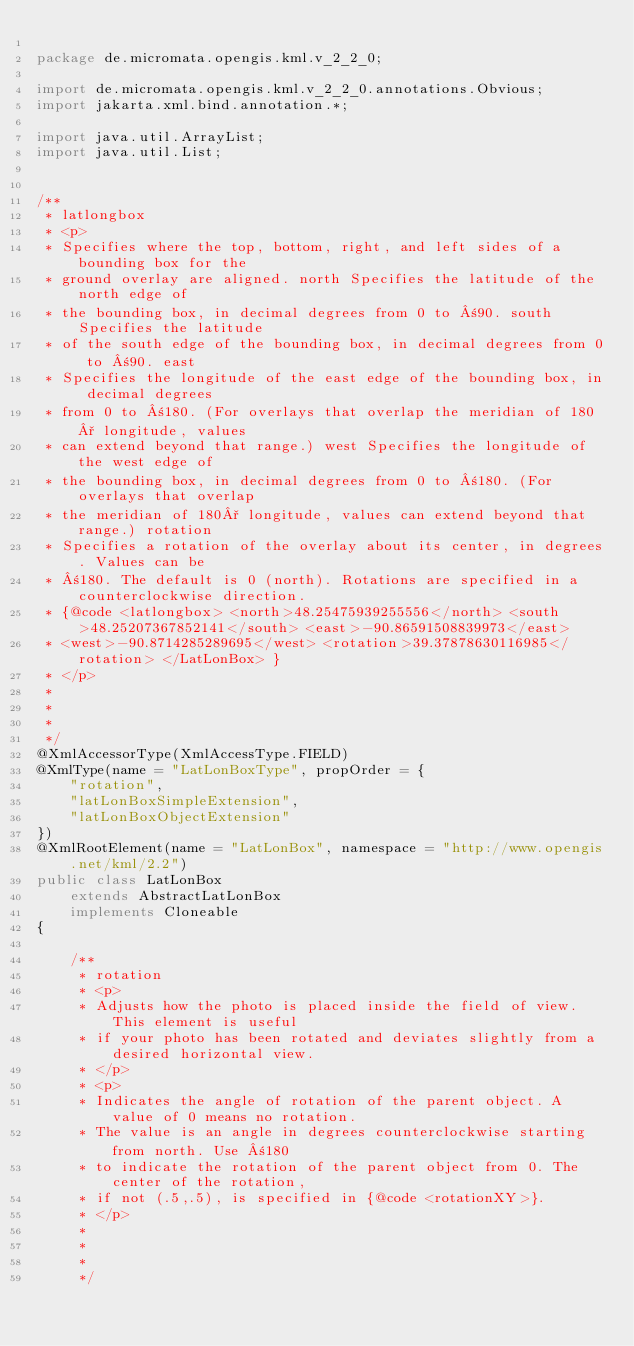<code> <loc_0><loc_0><loc_500><loc_500><_Java_>
package de.micromata.opengis.kml.v_2_2_0;

import de.micromata.opengis.kml.v_2_2_0.annotations.Obvious;
import jakarta.xml.bind.annotation.*;

import java.util.ArrayList;
import java.util.List;


/**
 * latlongbox
 * <p>
 * Specifies where the top, bottom, right, and left sides of a bounding box for the 
 * ground overlay are aligned. north Specifies the latitude of the north edge of 
 * the bounding box, in decimal degrees from 0 to ±90. south Specifies the latitude 
 * of the south edge of the bounding box, in decimal degrees from 0 to ±90. east 
 * Specifies the longitude of the east edge of the bounding box, in decimal degrees 
 * from 0 to ±180. (For overlays that overlap the meridian of 180° longitude, values 
 * can extend beyond that range.) west Specifies the longitude of the west edge of 
 * the bounding box, in decimal degrees from 0 to ±180. (For overlays that overlap 
 * the meridian of 180° longitude, values can extend beyond that range.) rotation 
 * Specifies a rotation of the overlay about its center, in degrees. Values can be 
 * ±180. The default is 0 (north). Rotations are specified in a counterclockwise direction. 
 * {@code <latlongbox> <north>48.25475939255556</north> <south>48.25207367852141</south> <east>-90.86591508839973</east>
 * <west>-90.8714285289695</west> <rotation>39.37878630116985</rotation> </LatLonBox> }
 * </p>
 * 
 * 
 * 
 */
@XmlAccessorType(XmlAccessType.FIELD)
@XmlType(name = "LatLonBoxType", propOrder = {
    "rotation",
    "latLonBoxSimpleExtension",
    "latLonBoxObjectExtension"
})
@XmlRootElement(name = "LatLonBox", namespace = "http://www.opengis.net/kml/2.2")
public class LatLonBox
    extends AbstractLatLonBox
    implements Cloneable
{

    /**
     * rotation
     * <p>
     * Adjusts how the photo is placed inside the field of view. This element is useful 
     * if your photo has been rotated and deviates slightly from a desired horizontal view. 
     * </p>
     * <p>
     * Indicates the angle of rotation of the parent object. A value of 0 means no rotation. 
     * The value is an angle in degrees counterclockwise starting from north. Use ±180 
     * to indicate the rotation of the parent object from 0. The center of the rotation, 
     * if not (.5,.5), is specified in {@code <rotationXY>}.
     * </p>
     * 
     * 
     * 
     */</code> 